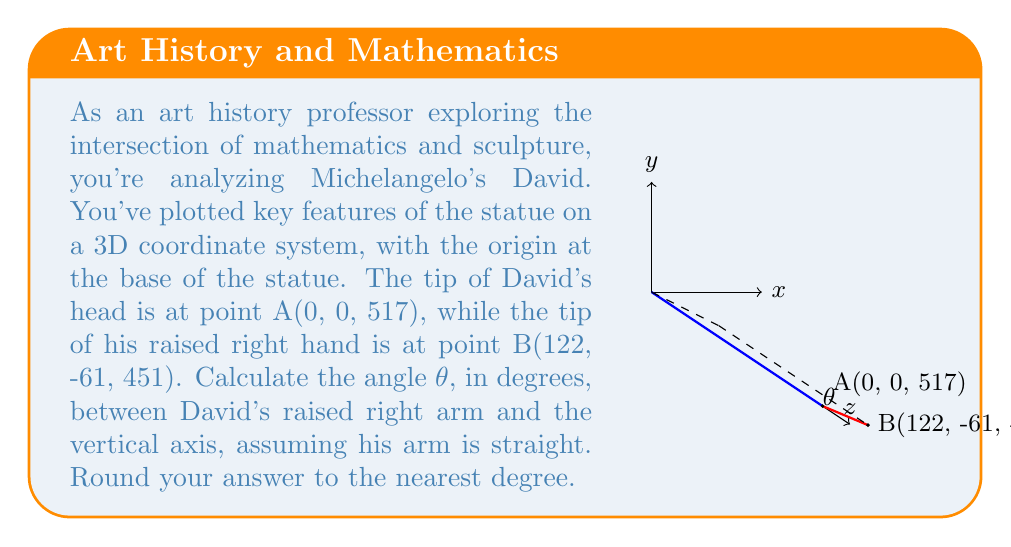Provide a solution to this math problem. To solve this problem, we'll follow these steps:

1) First, we need to find the vector $\vec{AB}$ representing David's arm:
   $\vec{AB} = B - A = (122-0, -61-0, 451-517) = (122, -61, -66)$

2) The angle θ is between this vector and the vertical axis (0, 0, 1). We can use the dot product formula to find this angle:

   $\cos \theta = \frac{\vec{AB} \cdot (0,0,1)}{|\vec{AB}||(0,0,1)|}$

3) Calculate the dot product $\vec{AB} \cdot (0,0,1)$:
   $(122, -61, -66) \cdot (0, 0, 1) = -66$

4) Calculate the magnitude of $\vec{AB}$:
   $|\vec{AB}| = \sqrt{122^2 + (-61)^2 + (-66)^2} = \sqrt{14884 + 3721 + 4356} = \sqrt{22961} \approx 151.53$

5) The magnitude of (0,0,1) is 1, so our equation becomes:

   $\cos \theta = \frac{-66}{151.53}$

6) Take the inverse cosine (arccos) of both sides:

   $\theta = \arccos(\frac{-66}{151.53})$

7) Calculate and convert to degrees:

   $\theta \approx 154.27°$

8) Rounding to the nearest degree:

   $\theta \approx 154°$
Answer: 154° 